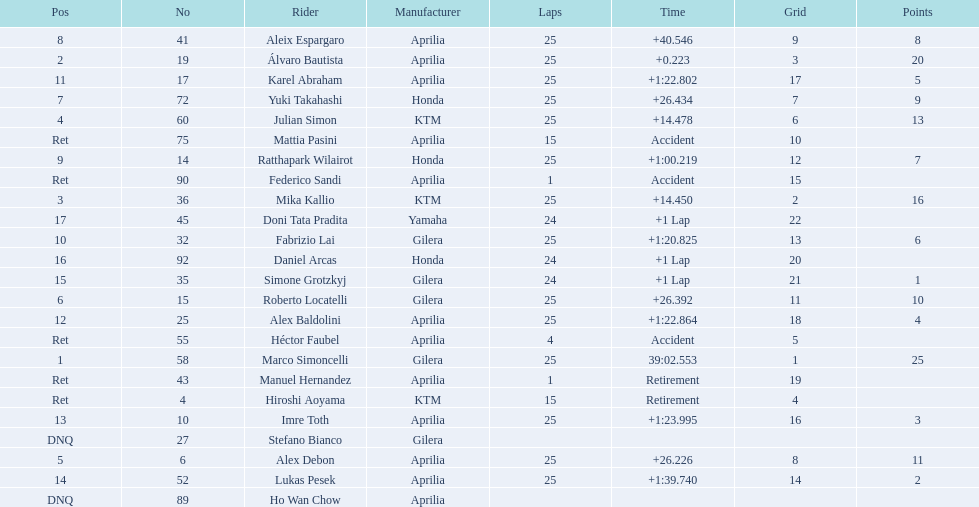The next rider from italy aside from winner marco simoncelli was Roberto Locatelli. 